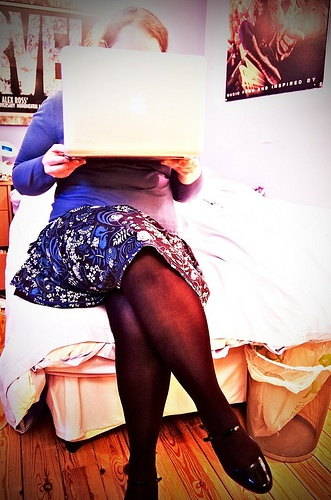Describe the objects in this image and their specific colors. I can see bed in black, white, and tan tones, people in black, maroon, white, and navy tones, and laptop in black, ivory, tan, and darkgray tones in this image. 